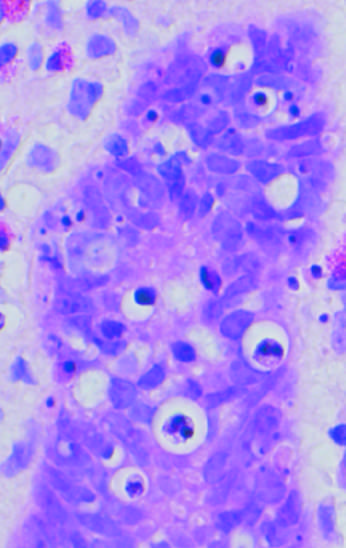re apoptotic cells in colonic epithelium shown?
Answer the question using a single word or phrase. Yes 